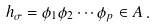Convert formula to latex. <formula><loc_0><loc_0><loc_500><loc_500>h _ { \sigma } = \phi _ { 1 } \phi _ { 2 } \cdots \phi _ { p } \in A \, .</formula> 